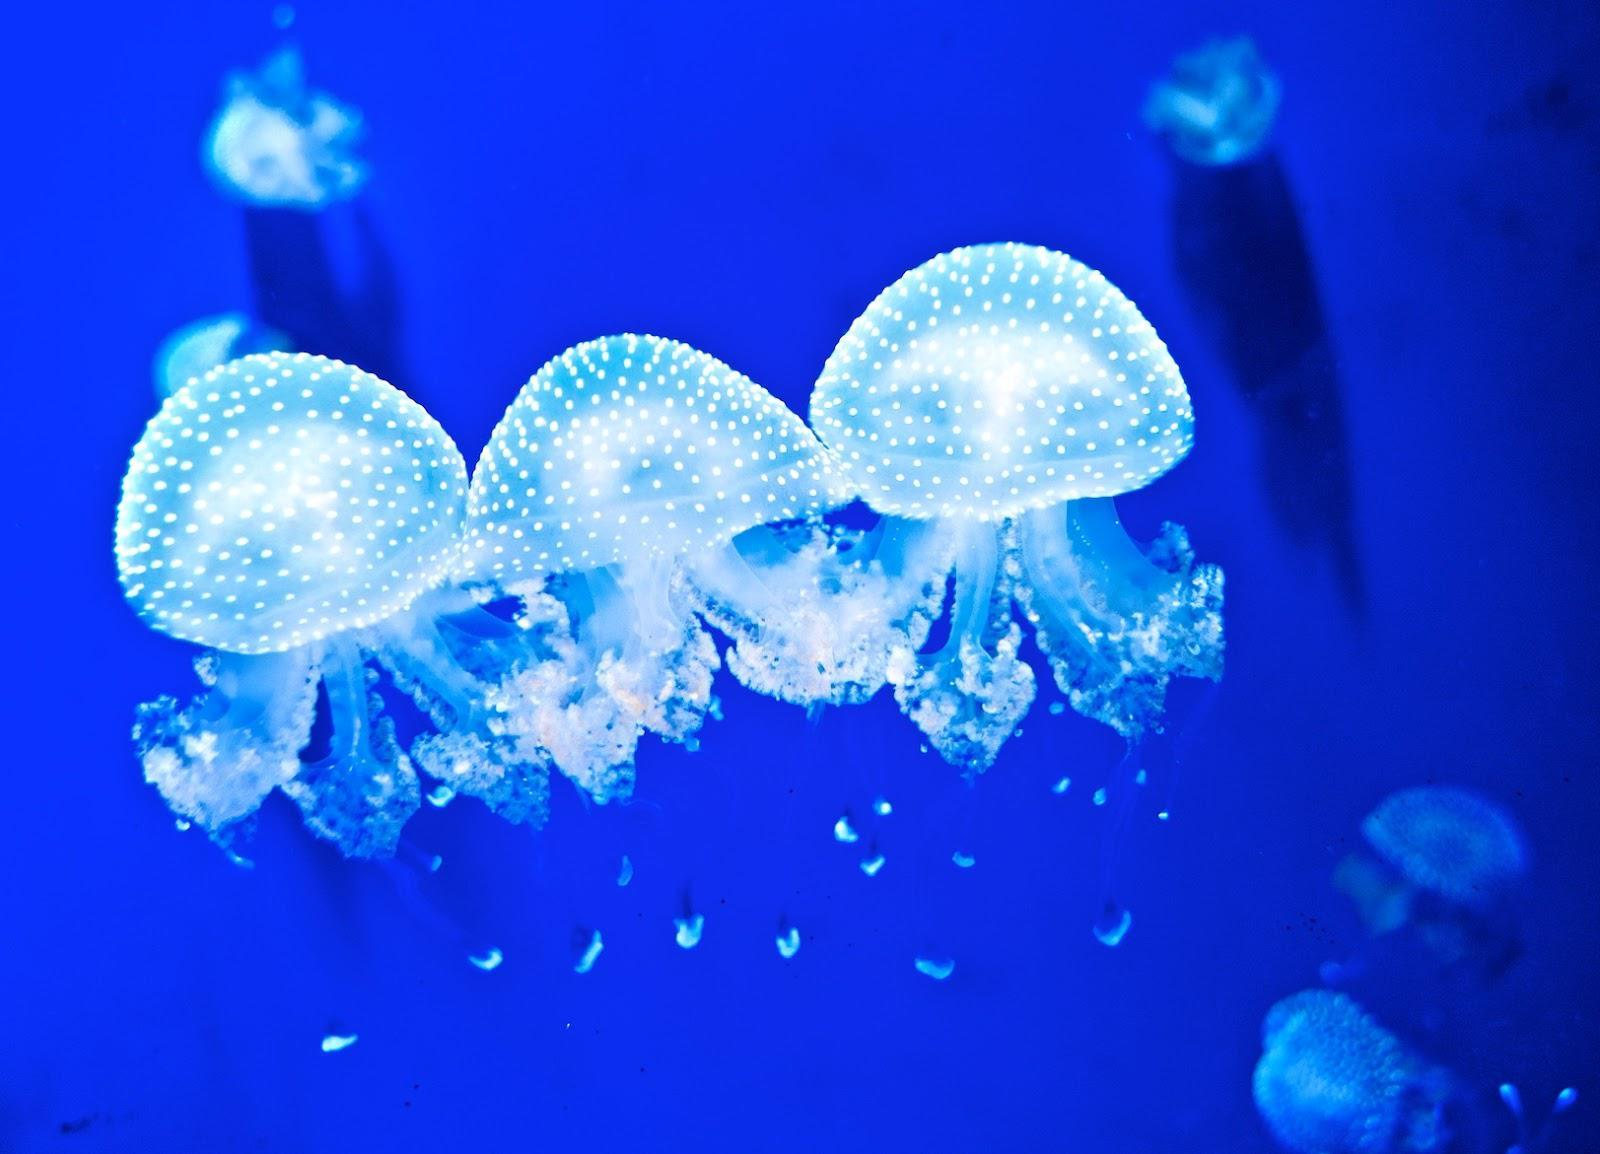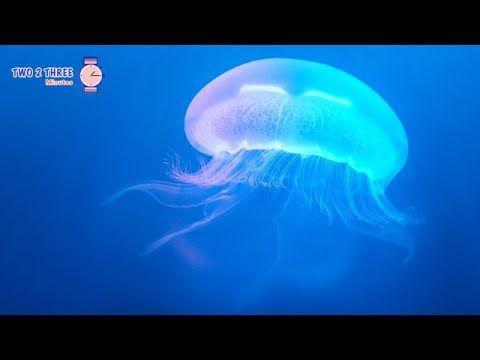The first image is the image on the left, the second image is the image on the right. For the images shown, is this caption "An image includes a jellyfish with long thread-like tendrils extending backward, to the right." true? Answer yes or no. No. The first image is the image on the left, the second image is the image on the right. Analyze the images presented: Is the assertion "The left image contains at least three jelly fish." valid? Answer yes or no. Yes. 